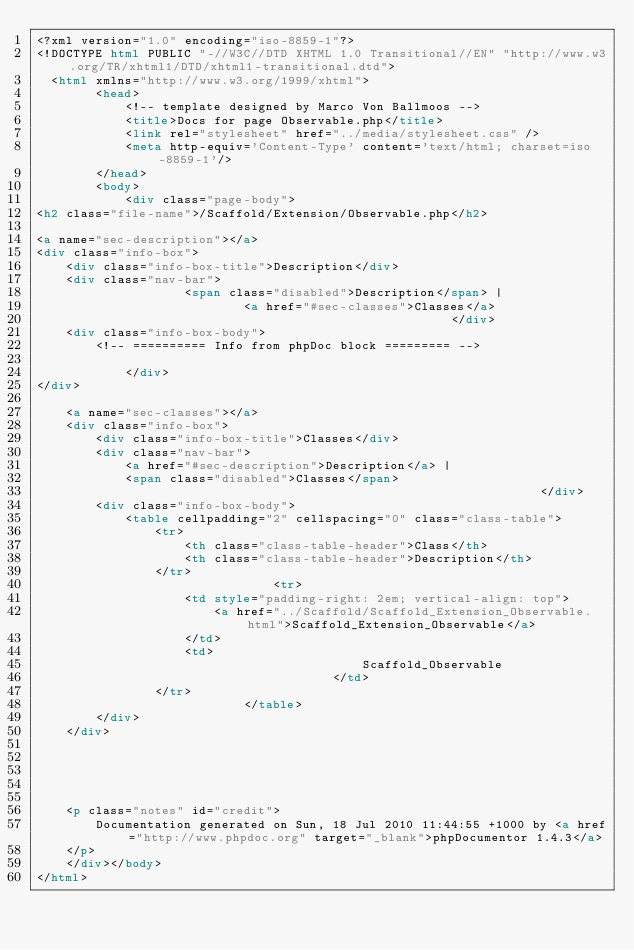<code> <loc_0><loc_0><loc_500><loc_500><_HTML_><?xml version="1.0" encoding="iso-8859-1"?>
<!DOCTYPE html PUBLIC "-//W3C//DTD XHTML 1.0 Transitional//EN" "http://www.w3.org/TR/xhtml1/DTD/xhtml1-transitional.dtd">
  <html xmlns="http://www.w3.org/1999/xhtml">
		<head>
			<!-- template designed by Marco Von Ballmoos -->
			<title>Docs for page Observable.php</title>
			<link rel="stylesheet" href="../media/stylesheet.css" />
			<meta http-equiv='Content-Type' content='text/html; charset=iso-8859-1'/>
		</head>
		<body>
			<div class="page-body">			
<h2 class="file-name">/Scaffold/Extension/Observable.php</h2>

<a name="sec-description"></a>
<div class="info-box">
	<div class="info-box-title">Description</div>
	<div class="nav-bar">
					<span class="disabled">Description</span> |
							<a href="#sec-classes">Classes</a>
														</div>
	<div class="info-box-body">	
		<!-- ========== Info from phpDoc block ========= -->
		
			</div>
</div>
		
	<a name="sec-classes"></a>	
	<div class="info-box">
		<div class="info-box-title">Classes</div>
		<div class="nav-bar">
			<a href="#sec-description">Description</a> |
			<span class="disabled">Classes</span>
																	</div>
		<div class="info-box-body">	
			<table cellpadding="2" cellspacing="0" class="class-table">
				<tr>
					<th class="class-table-header">Class</th>
					<th class="class-table-header">Description</th>
				</tr>
								<tr>
					<td style="padding-right: 2em; vertical-align: top">
						<a href="../Scaffold/Scaffold_Extension_Observable.html">Scaffold_Extension_Observable</a>
					</td>
					<td>
											Scaffold_Observable
										</td>
				</tr>
							</table>
		</div>
	</div>

	
	
	
	
	<p class="notes" id="credit">
		Documentation generated on Sun, 18 Jul 2010 11:44:55 +1000 by <a href="http://www.phpdoc.org" target="_blank">phpDocumentor 1.4.3</a>
	</p>
	</div></body>
</html></code> 